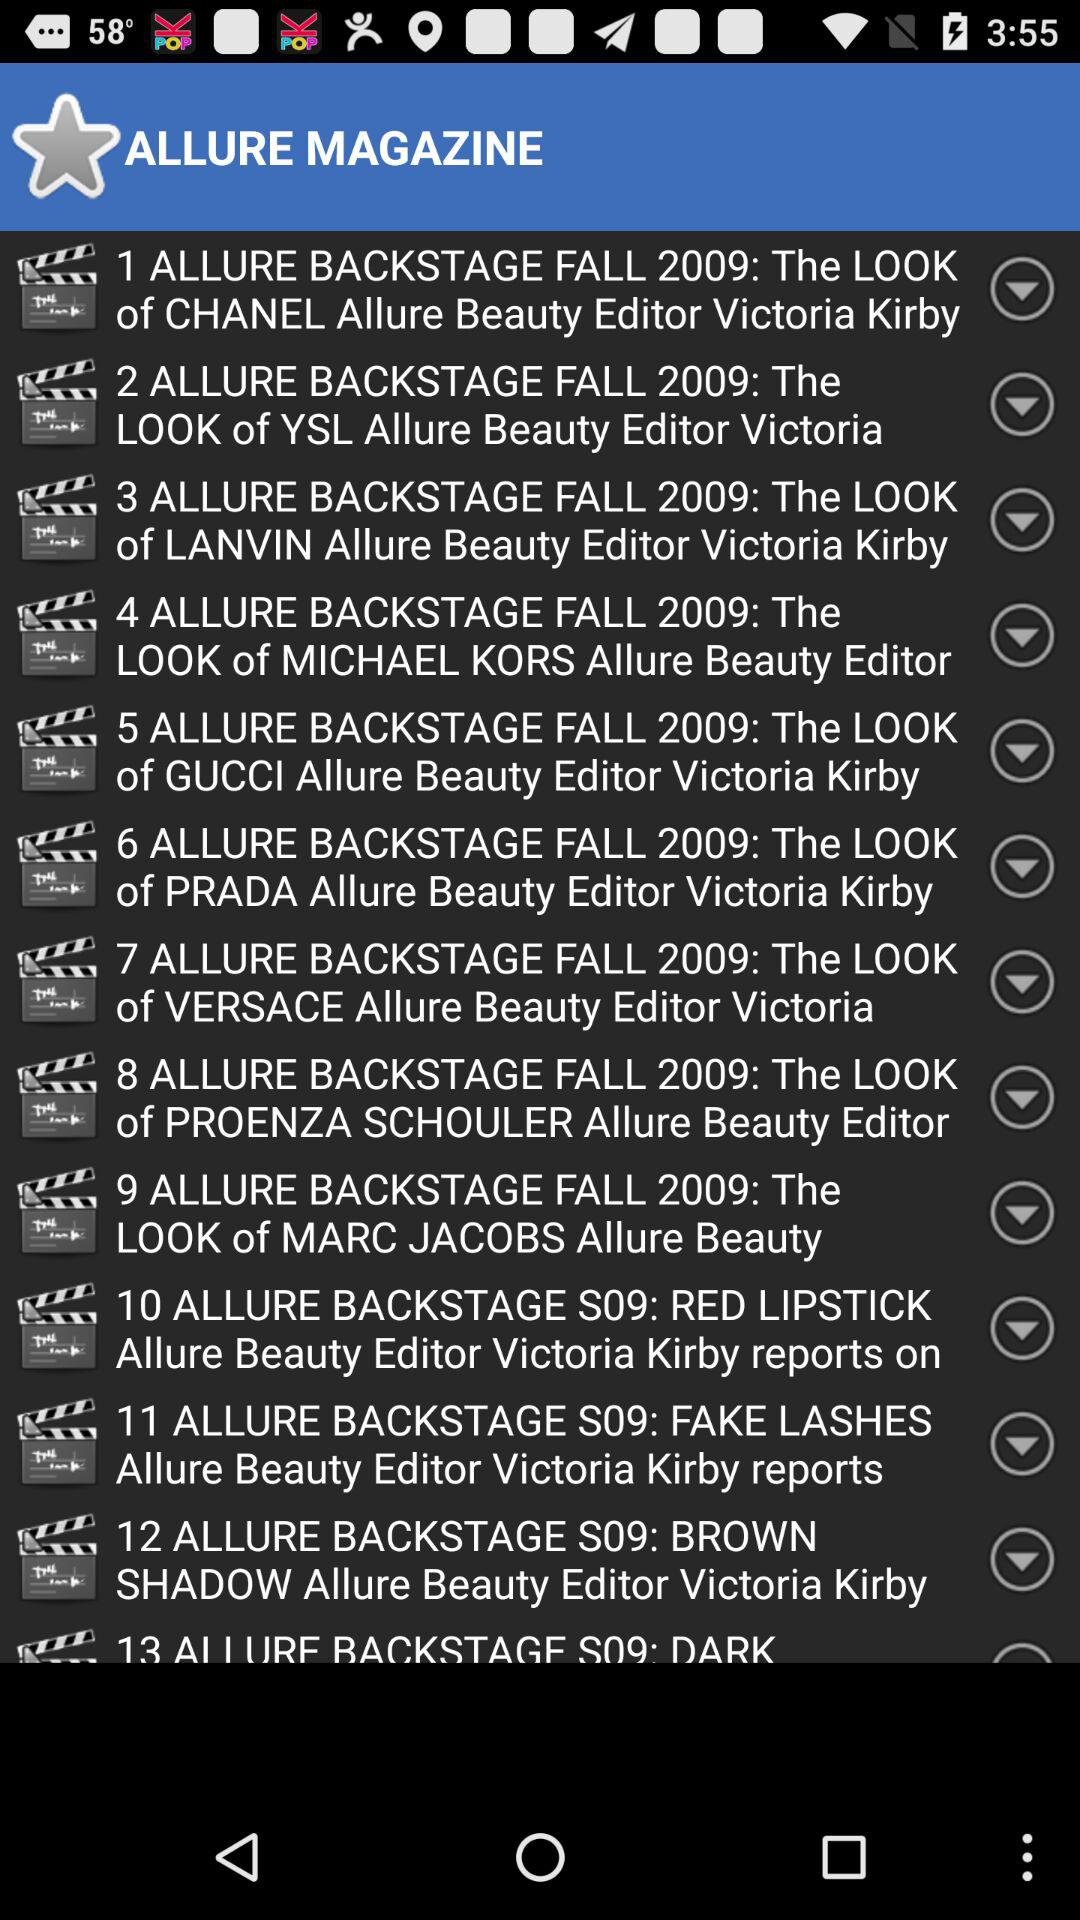What is the name of the application? The application name is Allure Magazine. 